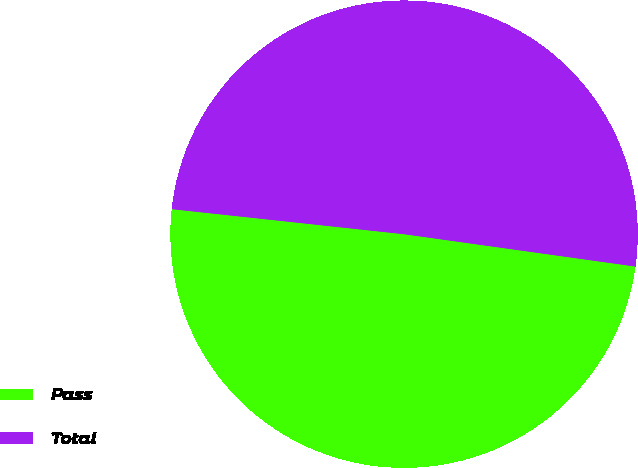Convert chart to OTSL. <chart><loc_0><loc_0><loc_500><loc_500><pie_chart><fcel>Pass<fcel>Total<nl><fcel>49.5%<fcel>50.5%<nl></chart> 